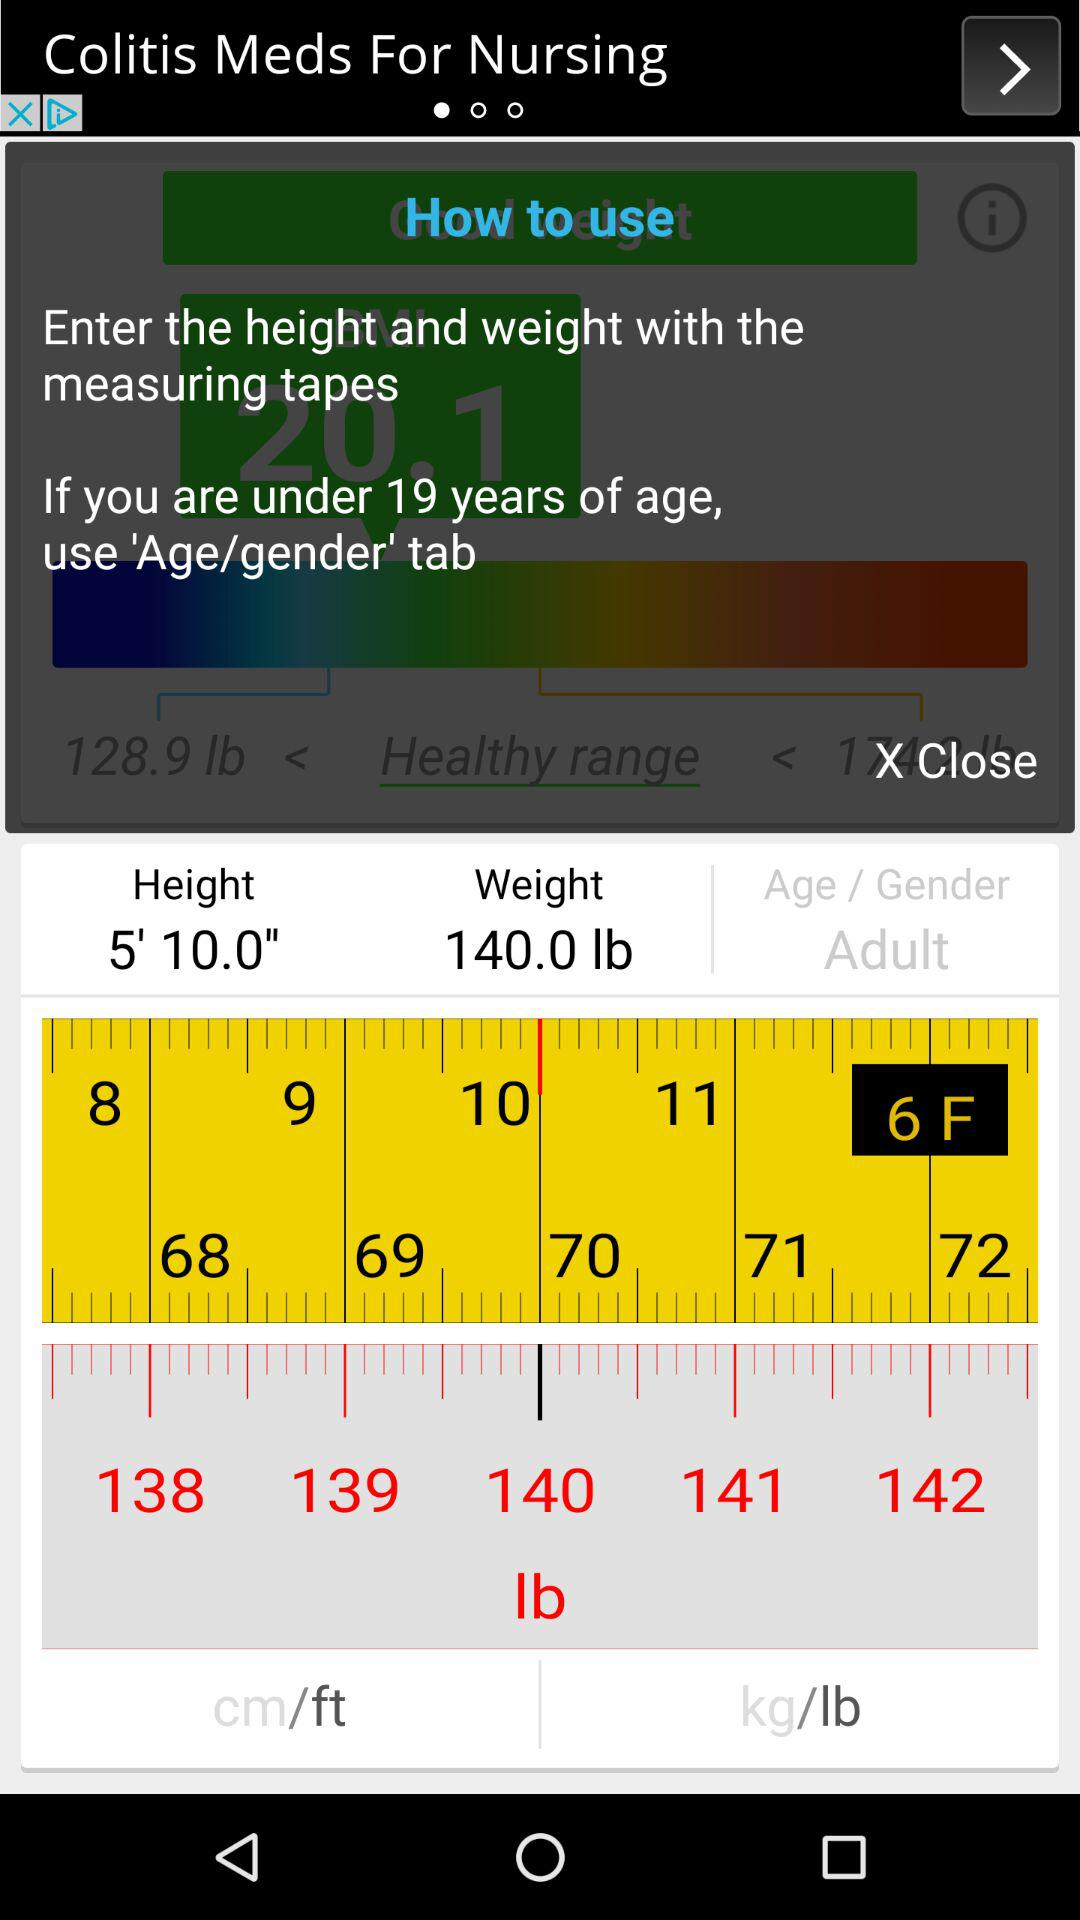What is the measuring unit of height and weight? The measuring units of height and weight are feet and pounds. 